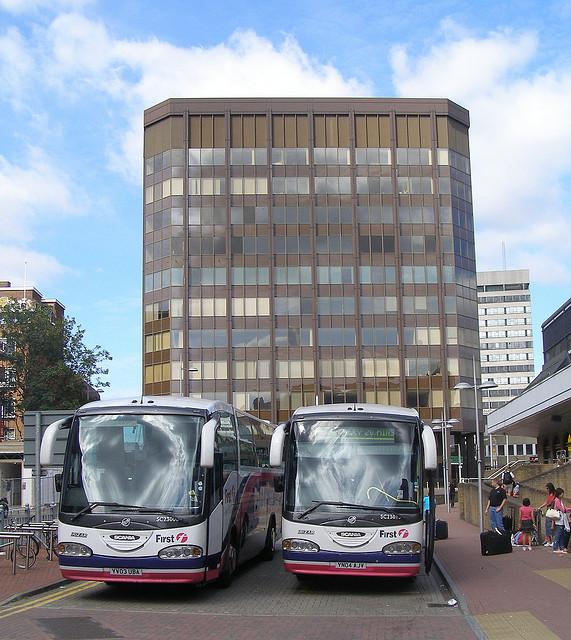What is the black bag on the sidewalk? luggage 